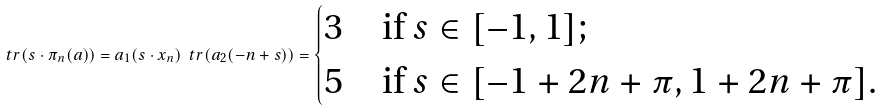<formula> <loc_0><loc_0><loc_500><loc_500>\ t r ( s \cdot \pi _ { n } ( a ) ) = a _ { 1 } ( s \cdot x _ { n } ) \ t r ( a _ { 2 } ( - n + s ) ) = \begin{cases} 3 & \text {if $s\in[-1,1]$} ; \\ 5 & \text {if $s\in[-1+2n+\pi,1+2n+\pi]$} . \end{cases}</formula> 